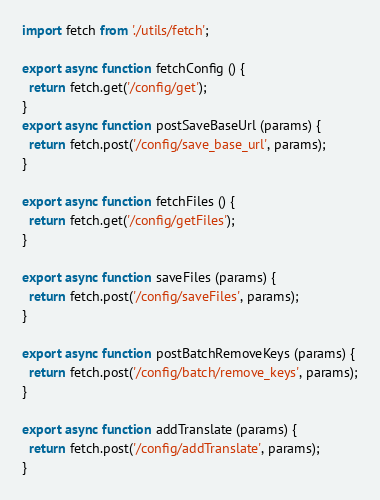<code> <loc_0><loc_0><loc_500><loc_500><_JavaScript_>import fetch from './utils/fetch';

export async function fetchConfig () {
  return fetch.get('/config/get');
}
export async function postSaveBaseUrl (params) {
  return fetch.post('/config/save_base_url', params);
}

export async function fetchFiles () {
  return fetch.get('/config/getFiles');
}

export async function saveFiles (params) {
  return fetch.post('/config/saveFiles', params);
}

export async function postBatchRemoveKeys (params) {
  return fetch.post('/config/batch/remove_keys', params);
}

export async function addTranslate (params) {
  return fetch.post('/config/addTranslate', params);
}
</code> 